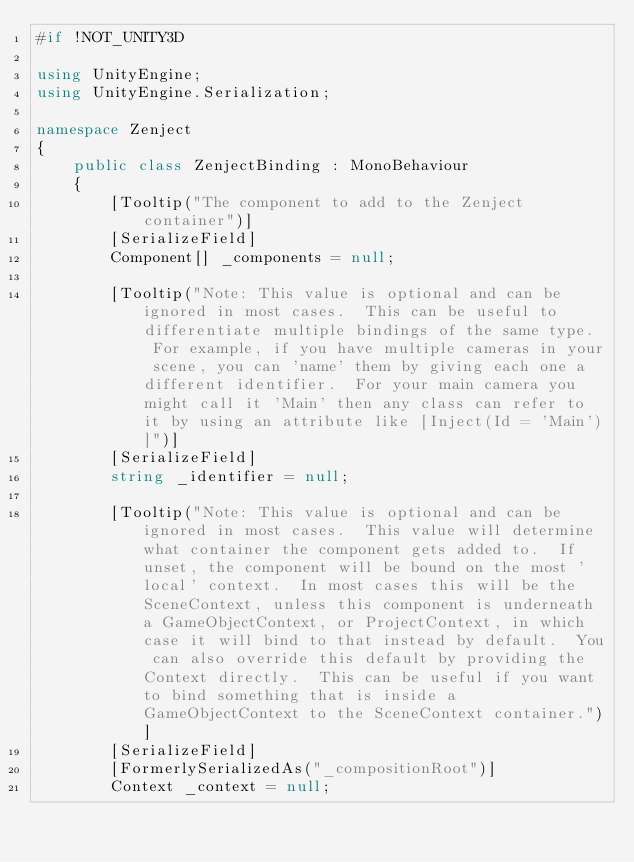<code> <loc_0><loc_0><loc_500><loc_500><_C#_>#if !NOT_UNITY3D

using UnityEngine;
using UnityEngine.Serialization;

namespace Zenject
{
    public class ZenjectBinding : MonoBehaviour
    {
        [Tooltip("The component to add to the Zenject container")]
        [SerializeField]
        Component[] _components = null;

        [Tooltip("Note: This value is optional and can be ignored in most cases.  This can be useful to differentiate multiple bindings of the same type.  For example, if you have multiple cameras in your scene, you can 'name' them by giving each one a different identifier.  For your main camera you might call it 'Main' then any class can refer to it by using an attribute like [Inject(Id = 'Main')]")]
        [SerializeField]
        string _identifier = null;

        [Tooltip("Note: This value is optional and can be ignored in most cases.  This value will determine what container the component gets added to.  If unset, the component will be bound on the most 'local' context.  In most cases this will be the SceneContext, unless this component is underneath a GameObjectContext, or ProjectContext, in which case it will bind to that instead by default.  You can also override this default by providing the Context directly.  This can be useful if you want to bind something that is inside a GameObjectContext to the SceneContext container.")]
        [SerializeField]
        [FormerlySerializedAs("_compositionRoot")]
        Context _context = null;
</code> 